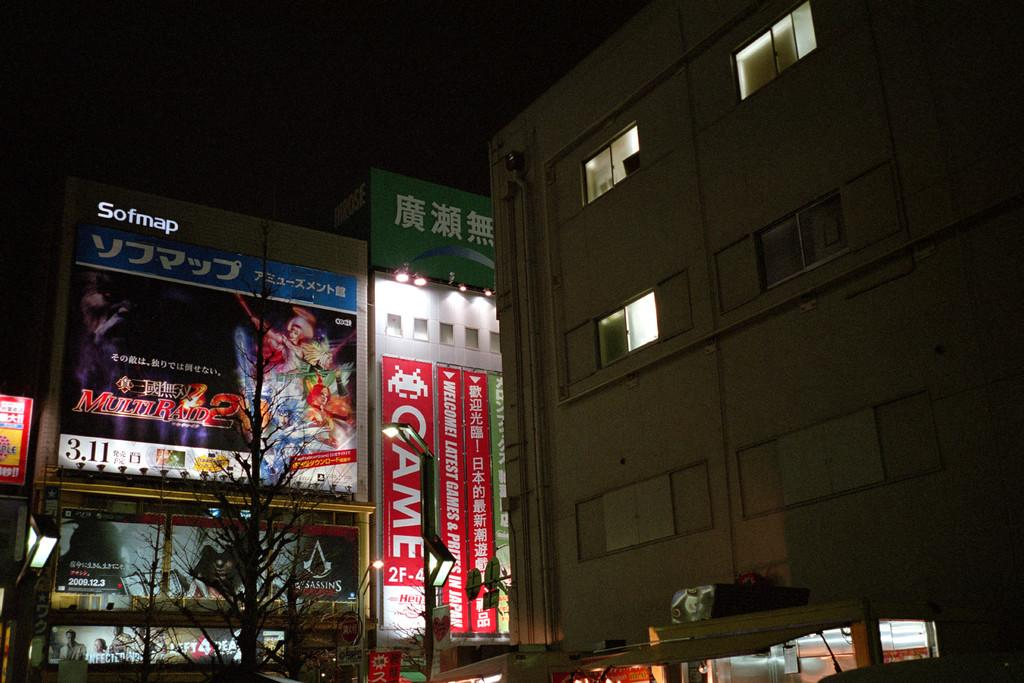What type of structure is present in the image? There is a building with a window in the image. What can be seen near the building? There are hoardings near the building. What is illuminating the area in the image? There are lights visible in the image, including a pole with a light near the building. What can be seen in the sky in the image? The sky is visible in the image. What type of meat can be seen hanging from the building in the image? There is no meat visible in the image; it features a building with a window, hoardings, lights, and a pole with a light. What type of cheese is present on the hoardings in the image? There is no cheese present on the hoardings in the image; they are advertising various products and services. 